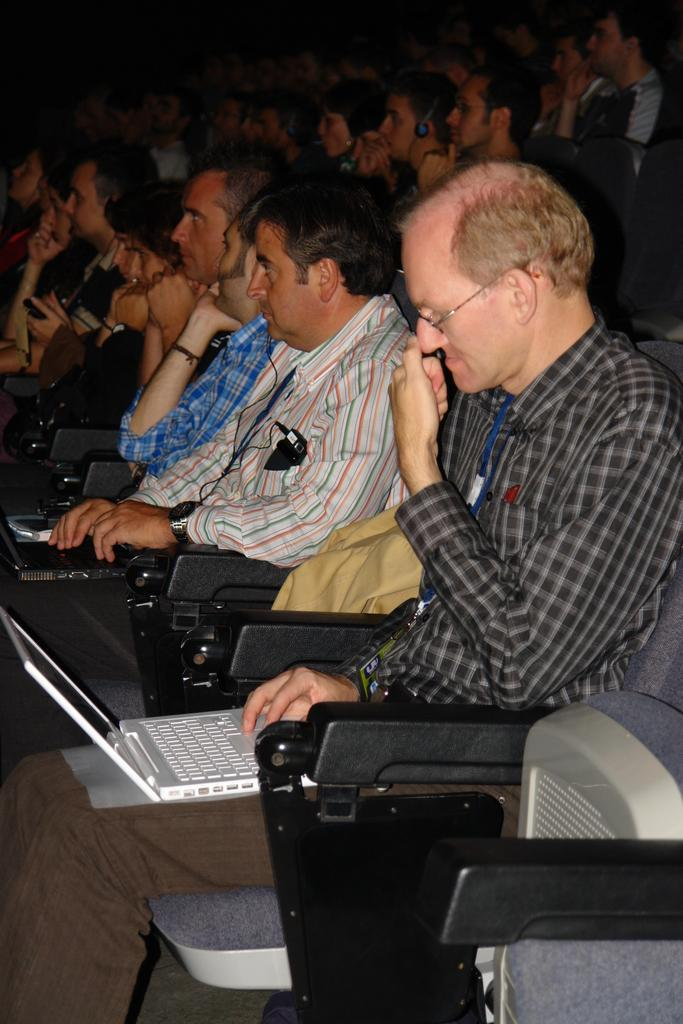What are the people in the image doing? There are people sitting on chairs in the image. What are the two persons using while sitting on the chairs? Two persons are using laptops in the image. Where are the laptops placed while being used? The laptops are placed on the laps of the two persons. What type of zinc is present in the image? There is no zinc present in the image. Can you describe the tramp in the image? There is no tramp present in the image. 